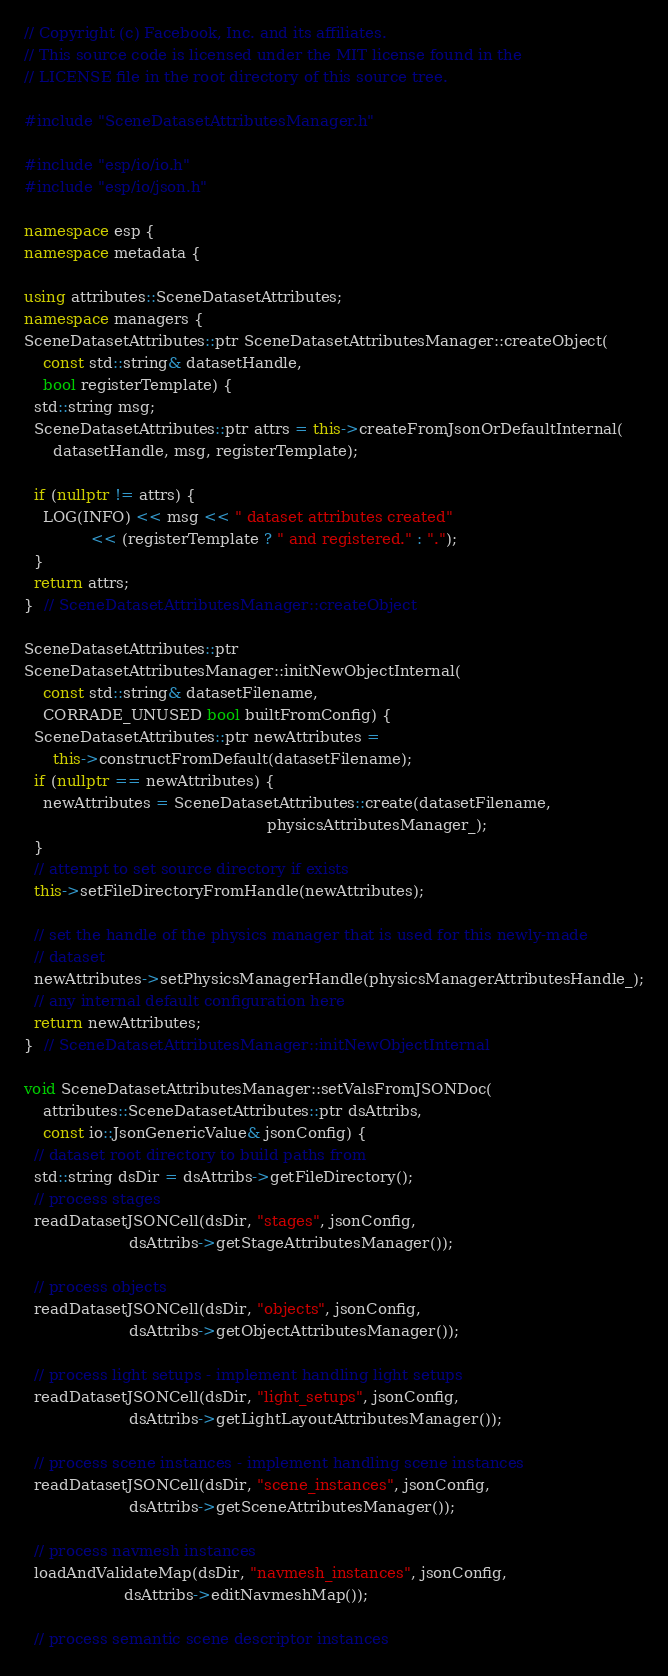Convert code to text. <code><loc_0><loc_0><loc_500><loc_500><_C++_>// Copyright (c) Facebook, Inc. and its affiliates.
// This source code is licensed under the MIT license found in the
// LICENSE file in the root directory of this source tree.

#include "SceneDatasetAttributesManager.h"

#include "esp/io/io.h"
#include "esp/io/json.h"

namespace esp {
namespace metadata {

using attributes::SceneDatasetAttributes;
namespace managers {
SceneDatasetAttributes::ptr SceneDatasetAttributesManager::createObject(
    const std::string& datasetHandle,
    bool registerTemplate) {
  std::string msg;
  SceneDatasetAttributes::ptr attrs = this->createFromJsonOrDefaultInternal(
      datasetHandle, msg, registerTemplate);

  if (nullptr != attrs) {
    LOG(INFO) << msg << " dataset attributes created"
              << (registerTemplate ? " and registered." : ".");
  }
  return attrs;
}  // SceneDatasetAttributesManager::createObject

SceneDatasetAttributes::ptr
SceneDatasetAttributesManager::initNewObjectInternal(
    const std::string& datasetFilename,
    CORRADE_UNUSED bool builtFromConfig) {
  SceneDatasetAttributes::ptr newAttributes =
      this->constructFromDefault(datasetFilename);
  if (nullptr == newAttributes) {
    newAttributes = SceneDatasetAttributes::create(datasetFilename,
                                                   physicsAttributesManager_);
  }
  // attempt to set source directory if exists
  this->setFileDirectoryFromHandle(newAttributes);

  // set the handle of the physics manager that is used for this newly-made
  // dataset
  newAttributes->setPhysicsManagerHandle(physicsManagerAttributesHandle_);
  // any internal default configuration here
  return newAttributes;
}  // SceneDatasetAttributesManager::initNewObjectInternal

void SceneDatasetAttributesManager::setValsFromJSONDoc(
    attributes::SceneDatasetAttributes::ptr dsAttribs,
    const io::JsonGenericValue& jsonConfig) {
  // dataset root directory to build paths from
  std::string dsDir = dsAttribs->getFileDirectory();
  // process stages
  readDatasetJSONCell(dsDir, "stages", jsonConfig,
                      dsAttribs->getStageAttributesManager());

  // process objects
  readDatasetJSONCell(dsDir, "objects", jsonConfig,
                      dsAttribs->getObjectAttributesManager());

  // process light setups - implement handling light setups
  readDatasetJSONCell(dsDir, "light_setups", jsonConfig,
                      dsAttribs->getLightLayoutAttributesManager());

  // process scene instances - implement handling scene instances
  readDatasetJSONCell(dsDir, "scene_instances", jsonConfig,
                      dsAttribs->getSceneAttributesManager());

  // process navmesh instances
  loadAndValidateMap(dsDir, "navmesh_instances", jsonConfig,
                     dsAttribs->editNavmeshMap());

  // process semantic scene descriptor instances</code> 